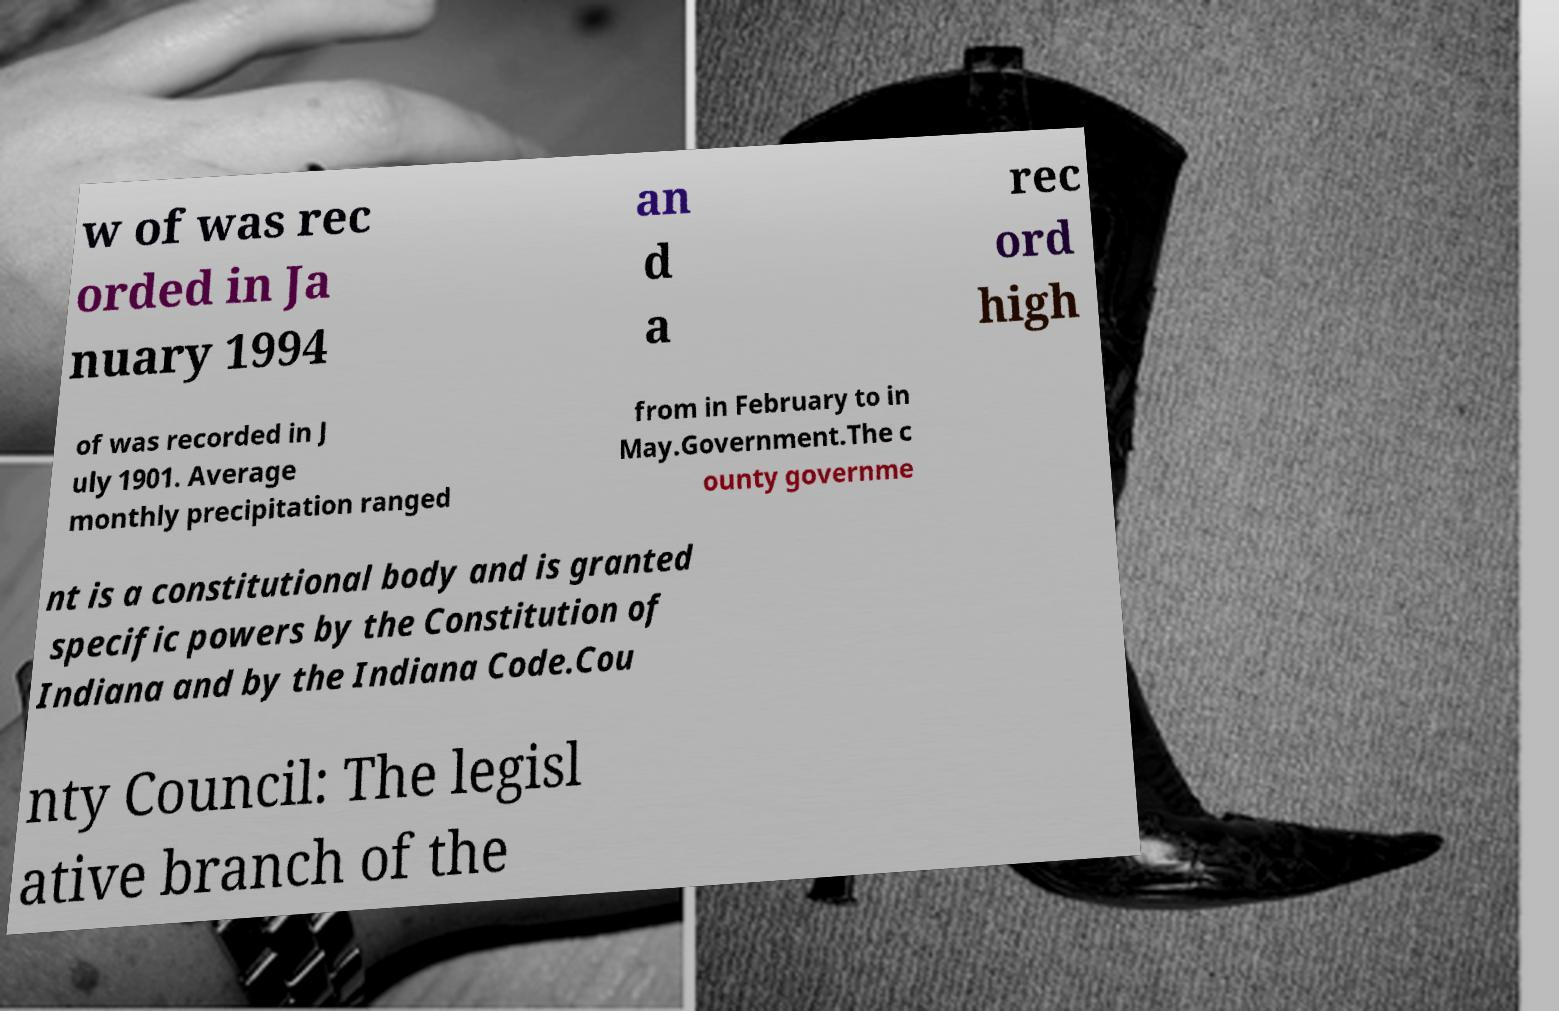Could you extract and type out the text from this image? w of was rec orded in Ja nuary 1994 an d a rec ord high of was recorded in J uly 1901. Average monthly precipitation ranged from in February to in May.Government.The c ounty governme nt is a constitutional body and is granted specific powers by the Constitution of Indiana and by the Indiana Code.Cou nty Council: The legisl ative branch of the 